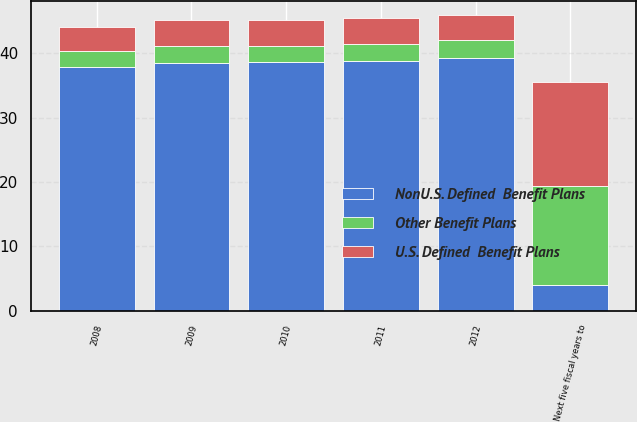Convert chart to OTSL. <chart><loc_0><loc_0><loc_500><loc_500><stacked_bar_chart><ecel><fcel>2008<fcel>2009<fcel>2010<fcel>2011<fcel>2012<fcel>Next five fiscal years to<nl><fcel>NonU.S. Defined  Benefit Plans<fcel>37.8<fcel>38.5<fcel>38.6<fcel>38.8<fcel>39.3<fcel>4<nl><fcel>Other Benefit Plans<fcel>2.5<fcel>2.6<fcel>2.6<fcel>2.7<fcel>2.8<fcel>15.3<nl><fcel>U.S. Defined  Benefit Plans<fcel>3.8<fcel>4<fcel>3.9<fcel>4<fcel>3.8<fcel>16.3<nl></chart> 